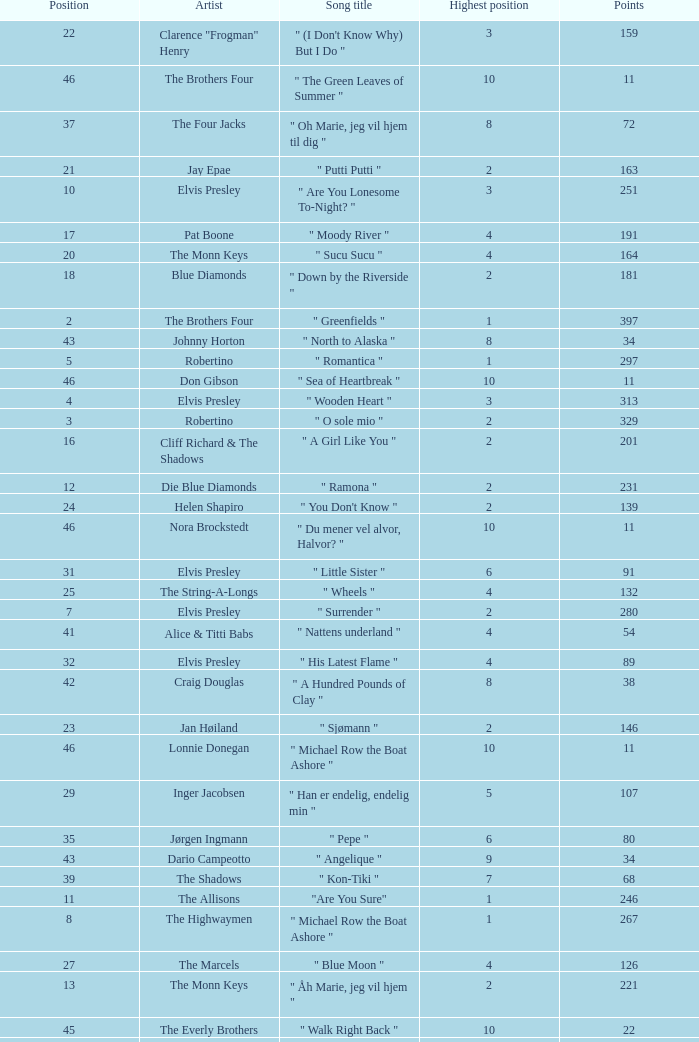What is the title of the song that received 259 points? " Babysitter-Boogie ". 